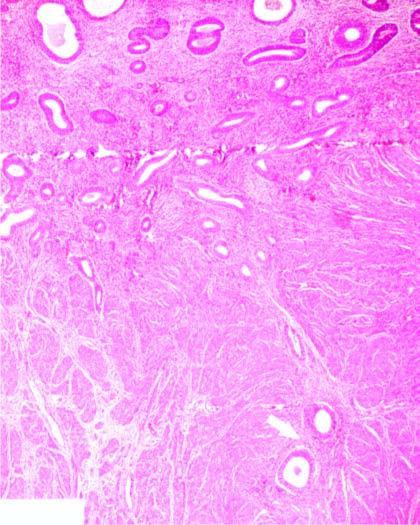re the endometrial glands present deep inside the myometrium?
Answer the question using a single word or phrase. Yes 